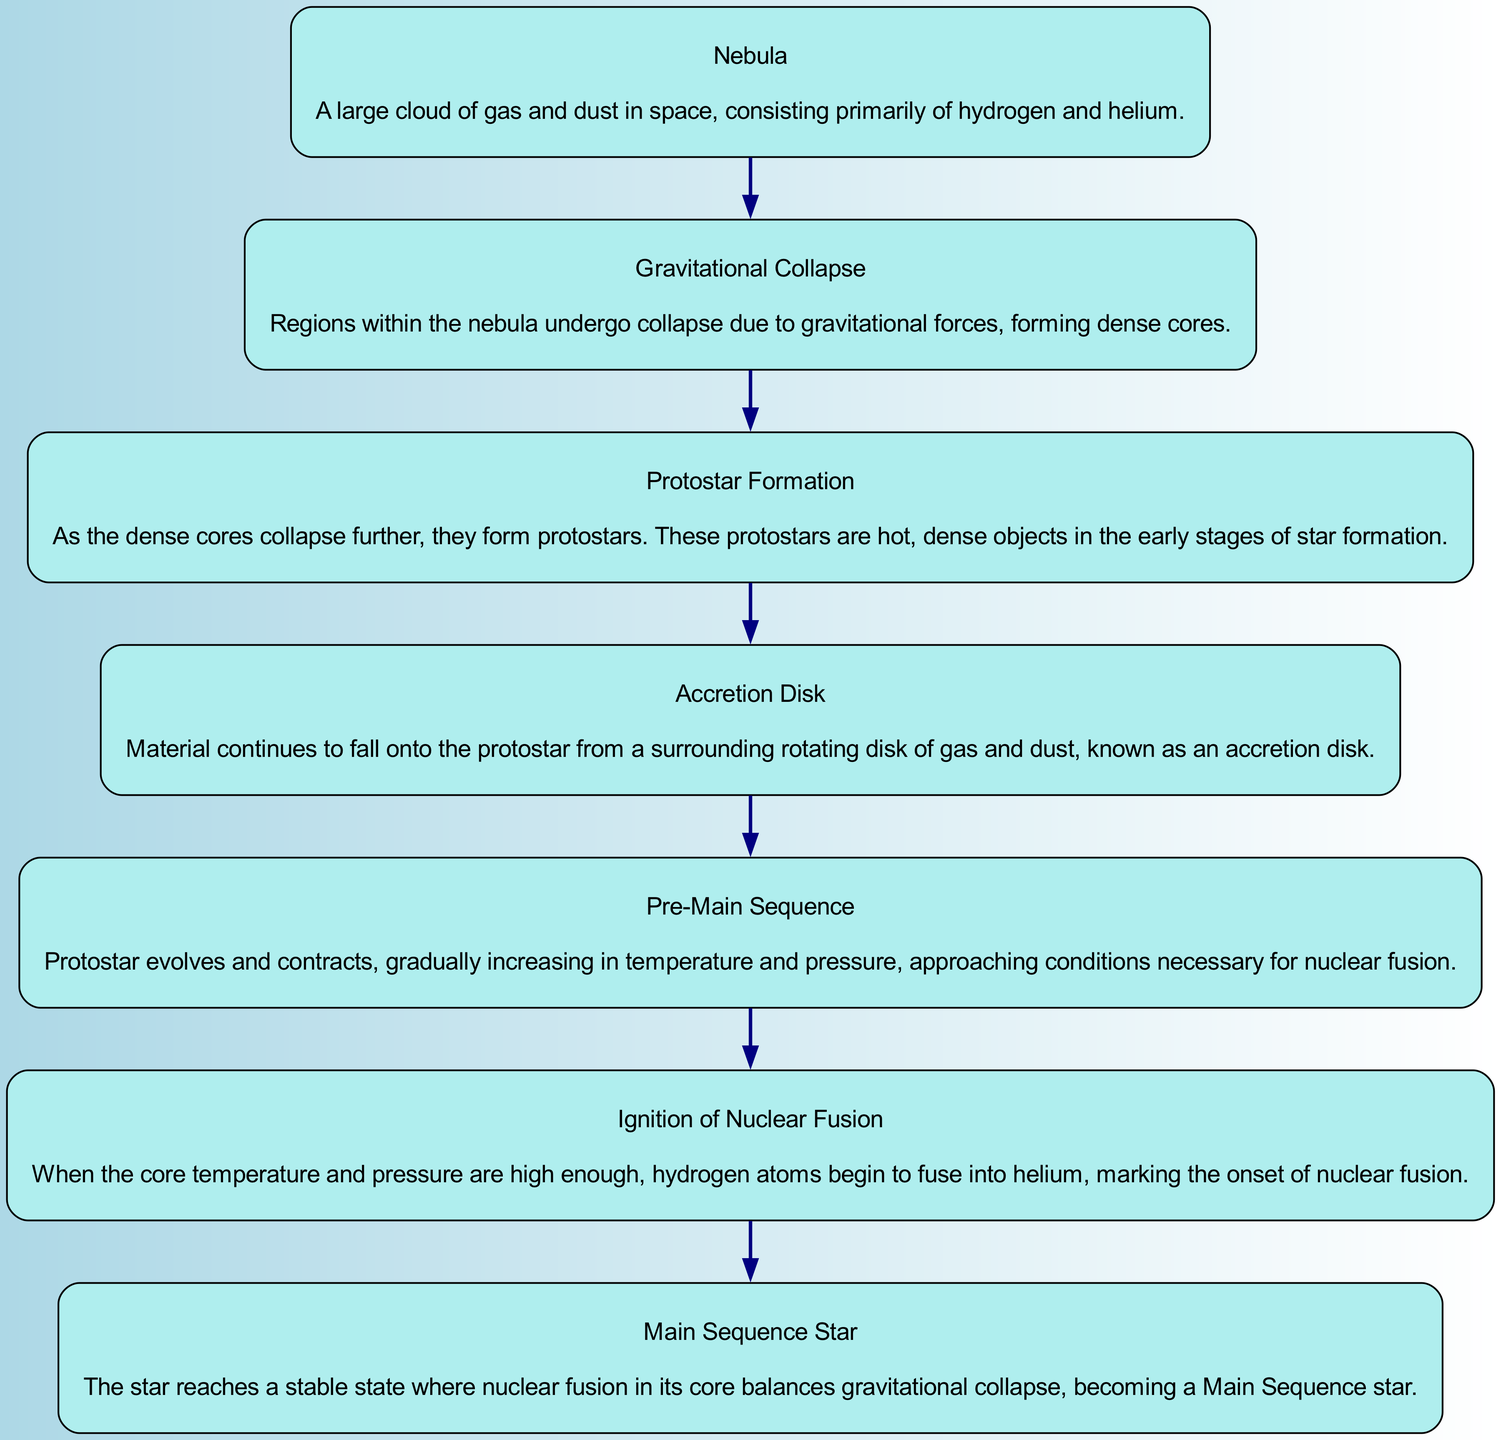What is the first stage in the star formation process? The diagram starts with the 'Nebula' stage, which is the first and foundational element before any other transformation occurs in the star formation process.
Answer: Nebula How many total stages are there in the star formation process? By counting the elements listed in the diagram, we find there are seven distinct stages from 'Nebula' to 'Main Sequence Star'.
Answer: 7 What happens after gravitational collapse? The flow from the 'Gravitational Collapse' stage leads directly to 'Protostar Formation', indicating that protostars are formed in the subsequent step after gravitational collapse occurs.
Answer: Protostar Formation What process marks the transition from pre-main sequence to main sequence star? The transition is marked by the 'Ignition of Nuclear Fusion', which occurs when the core reaches the necessary conditions for fusion, allowing the star to enter the main sequence phase.
Answer: Ignition of Nuclear Fusion What is the final state in the diagram? Following the last transformation indicated in the flow chart, the star reaches its stable form as a 'Main Sequence Star', which is the endpoint of the outlined star formation stages.
Answer: Main Sequence Star Which stage indicates the formation of a denser structure? The 'Gravitational Collapse' stage indicates the process where regions of the nebula collapse under gravity, resulting in the formation of dense cores from which protostars form.
Answer: Gravitational Collapse What is the key feature of the accretion disk stage? The description highlights that the 'Accretion Disk' is characterized by material falling onto the protostar from a surrounding rotating disk of gas and dust surrounding it.
Answer: Rotating disk of gas and dust Which stage directly follows protostar formation? According to the flow of the diagram, the stage that follows 'Protostar Formation' is the 'Accretion Disk' stage, where material continues to accumulate around the protostar.
Answer: Accretion Disk 